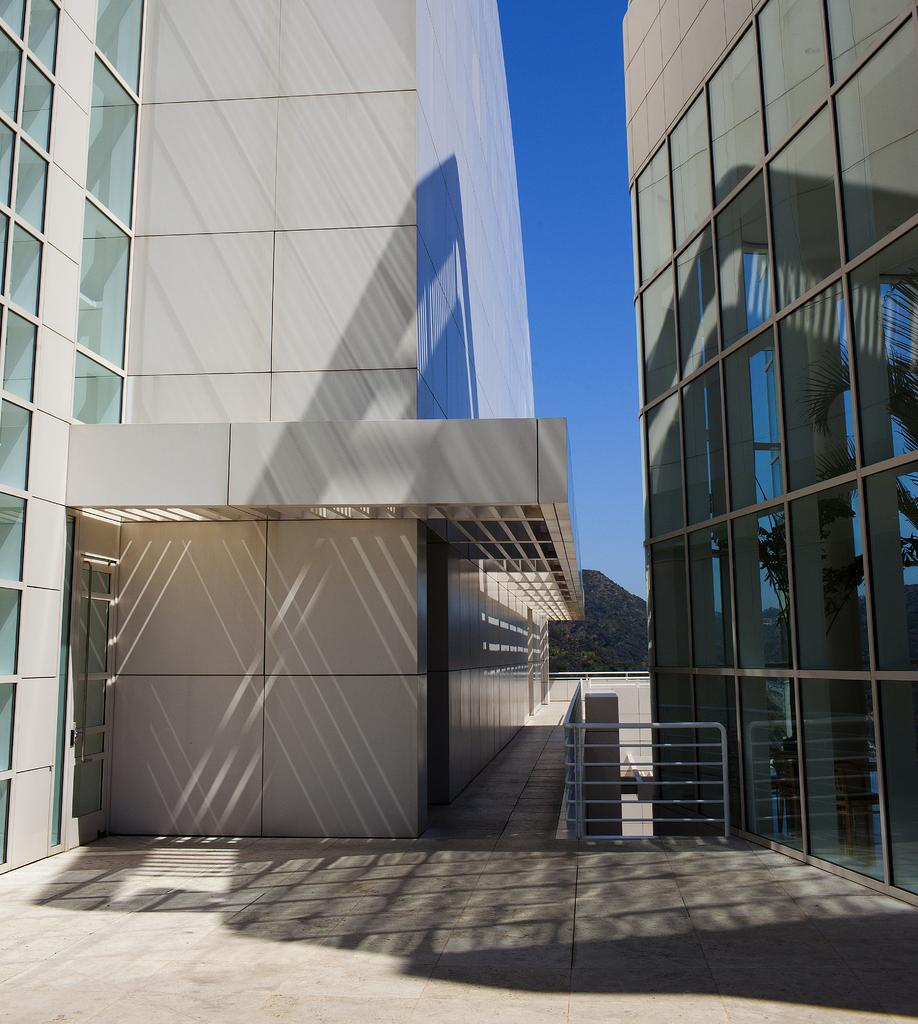What type of structures can be seen in the image? There are buildings in the image. What feature is present in the foreground of the image? There is a railing in the image. What can be seen in the distance in the image? There are trees in the background of the image. What is visible in the sky in the image? The sky is visible in the background of the image. Where is the desk located in the image? There is no desk present in the image. What type of produce can be seen growing on the trees in the image? There are no trees with produce visible in the image; only the trees themselves are present. 